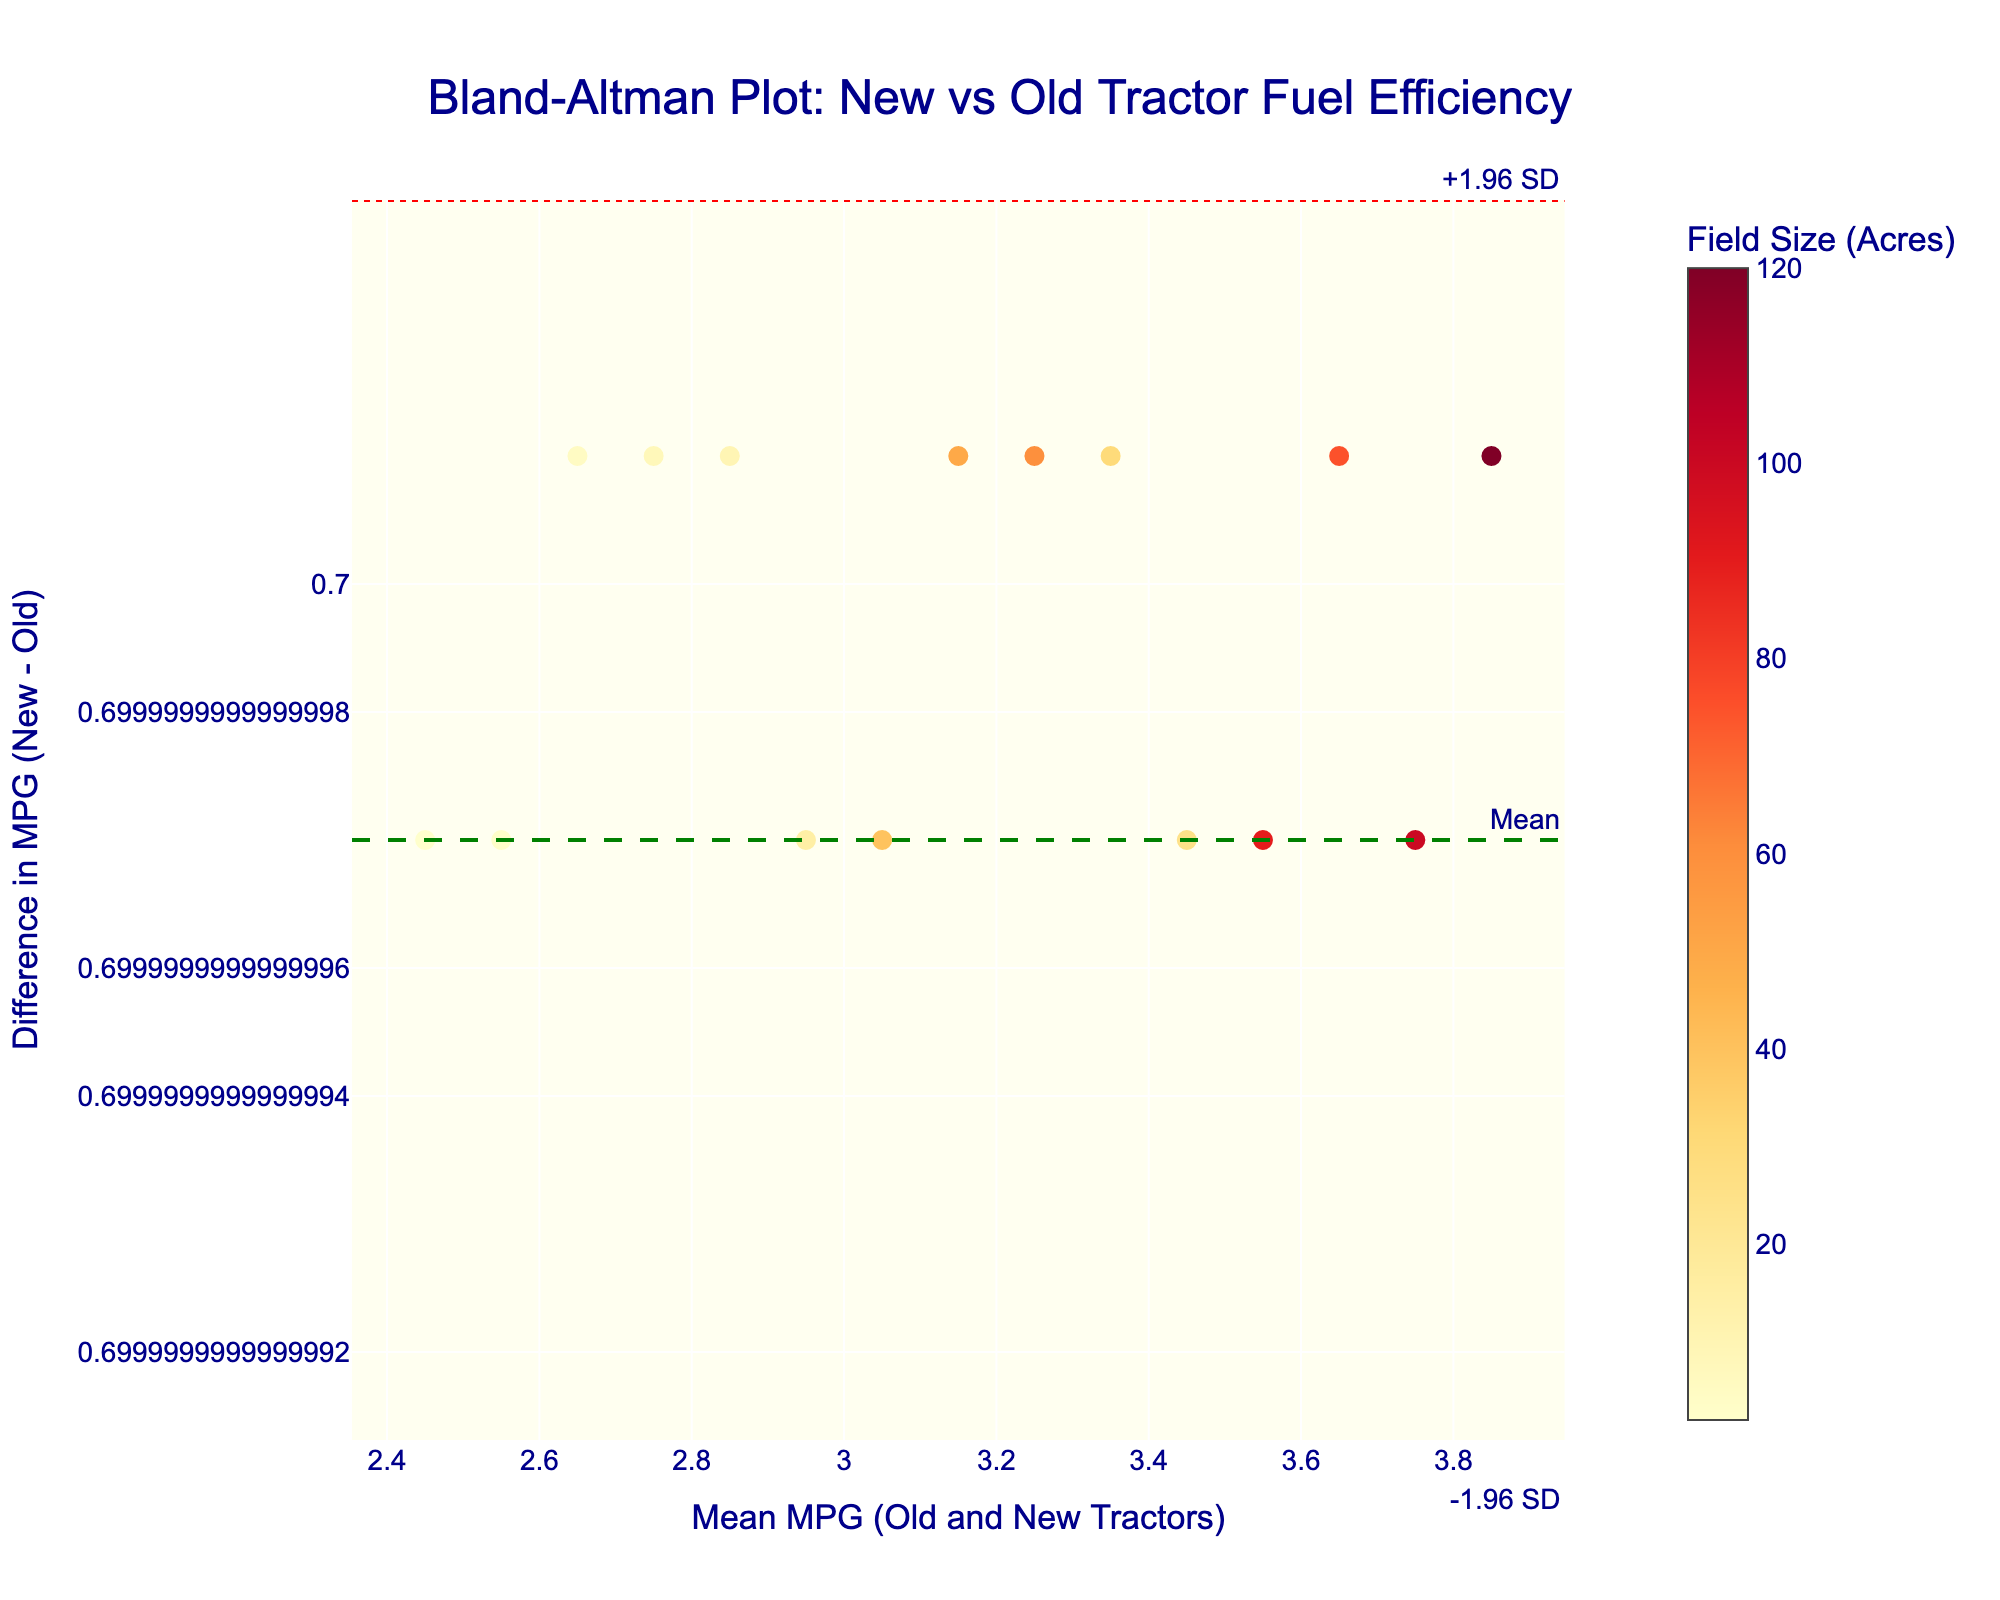What is the title of the figure? The title of the figure is displayed prominently at the top. It reads "Bland-Altman Plot: New vs Old Tractor Fuel Efficiency".
Answer: Bland-Altman Plot: New vs Old Tractor Fuel Efficiency How is the field size represented in the plot? The field size is represented by the color of the markers. There is a color bar on the right side of the plot indicating that larger field sizes are colored in darker shades of red.
Answer: By the color of the markers How many data points are there in the plot? Each data point represents a different measurement. By counting the markers in the plot, you can determine there are 15 data points.
Answer: 15 What is the mean difference between the new and old tractor MPG? The mean difference is indicated by the green dashed line, which is labeled "Mean". The y-value of this line represents the mean difference.
Answer: Approx. 0.7 What are the upper and lower limits of agreement (LOA) in the plot? The upper and lower LOA are indicated by the red dotted lines in the plot. The upper LOA is labeled "+1.96 SD" and the lower LOA is labeled "-1.96 SD". The y-values of these lines represent the LOA.
Answer: Approx. 1.2 and 0.2 Which field size corresponds to the biggest difference in MPG between the new and old tractors? To find this, look for the marker that is the furthest from the y-value of 0 (which represents no difference). Checking the hovertext by looking at the markers, the biggest difference appears to be around 120 acres.
Answer: 120 acres What is the mean MPG for the old and new tractors when the field size is 75 acres? Check the color bar to find the marker color for 75 acres, and then locate its x-position which represents the mean MPG. The mean MPG can be identified as around 3.65.
Answer: Approx. 3.65 How does the difference in MPG between the new and old tractors vary with the field size? Analyze the colors of the markers representing different field sizes. Generally, larger field sizes (darker colors) seem to correspond with a greater difference (markers further from the x-axis). This suggests a trend where larger fields might see a bigger MPG gain with the new tractor.
Answer: Larger fields have a higher MPG difference Are there any measurements where the new and old tractors have almost the same MPG efficiency? Look for markers that are close to the y-value of 0, which signifies minimal difference in MPG between the two tractors. Some markers representing small field sizes show nearly no difference.
Answer: Yes, for small fields Which field size has a mean MPG closest to 2.8? Find the closest marker on the x-axis to 2.8 mean MPG. The corresponding hovertext indicates this field size. The closest field size appears to be 2 acres.
Answer: 2 acres 